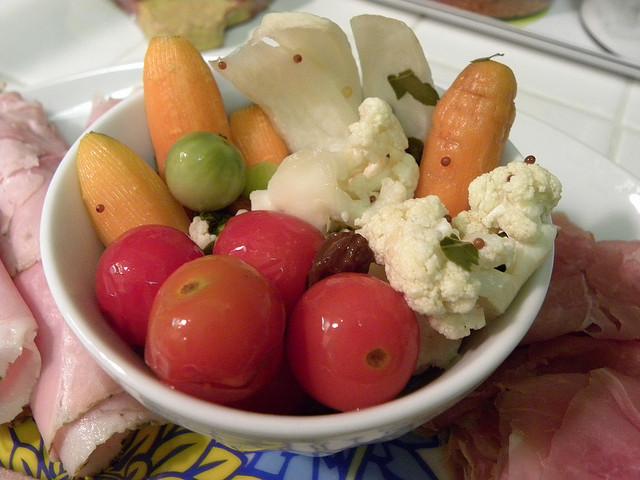Is the entire bowl in the frame?
Be succinct. Yes. How many types of food are in the cup?
Be succinct. 6. What are the red objects?
Quick response, please. Tomatoes. How many calories are in this bowl?
Give a very brief answer. 100. What is the food served on?
Give a very brief answer. Bowl. What fruits are in this picture?
Answer briefly. None. 